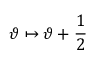Convert formula to latex. <formula><loc_0><loc_0><loc_500><loc_500>\vartheta \mapsto \vartheta + \frac { 1 } { 2 } \,</formula> 